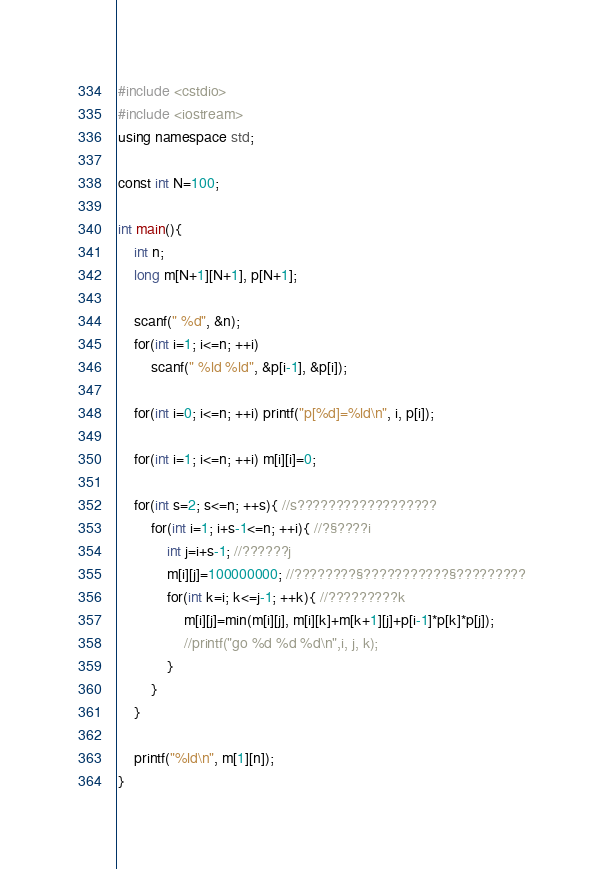<code> <loc_0><loc_0><loc_500><loc_500><_C++_>#include <cstdio>
#include <iostream>
using namespace std;

const int N=100;

int main(){
	int n;
	long m[N+1][N+1], p[N+1];
	
	scanf(" %d", &n);
	for(int i=1; i<=n; ++i)
		scanf(" %ld %ld", &p[i-1], &p[i]);
		
	for(int i=0; i<=n; ++i) printf("p[%d]=%ld\n", i, p[i]);
		
	for(int i=1; i<=n; ++i) m[i][i]=0;
	
	for(int s=2; s<=n; ++s){ //s??????????????????
		for(int i=1; i+s-1<=n; ++i){ //?§????i
			int j=i+s-1; //??????j
			m[i][j]=100000000; //????????§???????????§?????????
			for(int k=i; k<=j-1; ++k){ //?????????k
				m[i][j]=min(m[i][j], m[i][k]+m[k+1][j]+p[i-1]*p[k]*p[j]);
				//printf("go %d %d %d\n",i, j, k);
			}
		}
	}
	
	printf("%ld\n", m[1][n]);
}</code> 